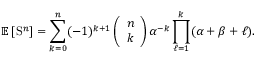<formula> <loc_0><loc_0><loc_500><loc_500>\mathbb { E } \left [ S ^ { n } \right ] = \sum _ { k = 0 } ^ { n } ( - 1 ) ^ { k + 1 } \left ( \begin{array} { l } { n } \\ { k } \end{array} \right ) \alpha ^ { - k } \prod _ { \ell = 1 } ^ { k } ( \alpha + \beta + \ell ) .</formula> 